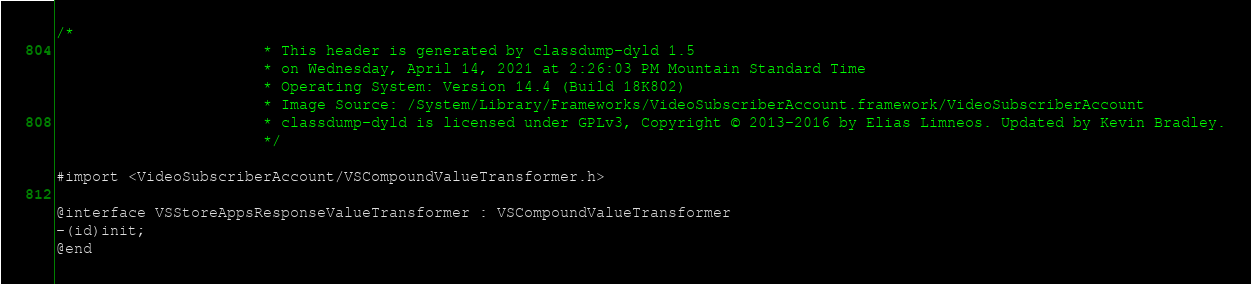<code> <loc_0><loc_0><loc_500><loc_500><_C_>/*
                       * This header is generated by classdump-dyld 1.5
                       * on Wednesday, April 14, 2021 at 2:26:03 PM Mountain Standard Time
                       * Operating System: Version 14.4 (Build 18K802)
                       * Image Source: /System/Library/Frameworks/VideoSubscriberAccount.framework/VideoSubscriberAccount
                       * classdump-dyld is licensed under GPLv3, Copyright © 2013-2016 by Elias Limneos. Updated by Kevin Bradley.
                       */

#import <VideoSubscriberAccount/VSCompoundValueTransformer.h>

@interface VSStoreAppsResponseValueTransformer : VSCompoundValueTransformer
-(id)init;
@end

</code> 